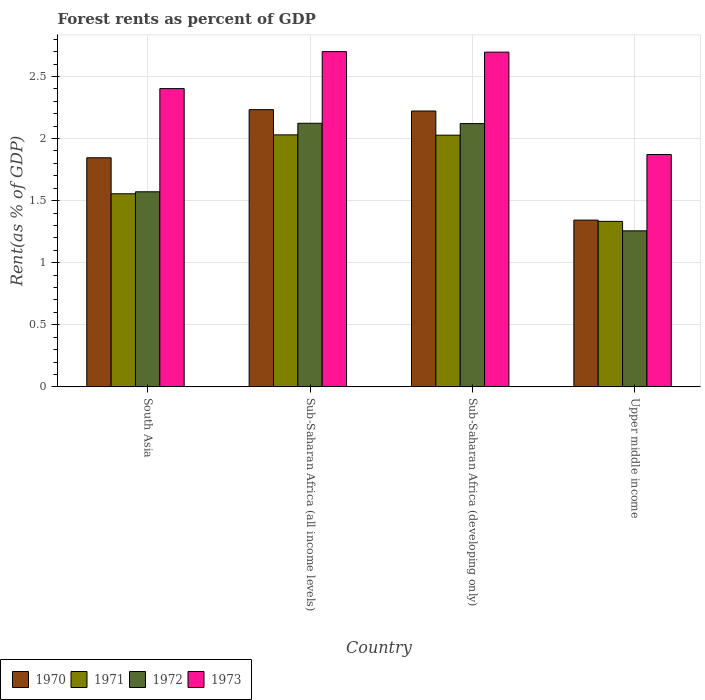How many different coloured bars are there?
Offer a terse response. 4. Are the number of bars per tick equal to the number of legend labels?
Offer a very short reply. Yes. How many bars are there on the 3rd tick from the left?
Provide a succinct answer. 4. What is the label of the 2nd group of bars from the left?
Provide a succinct answer. Sub-Saharan Africa (all income levels). What is the forest rent in 1973 in Sub-Saharan Africa (all income levels)?
Your answer should be very brief. 2.7. Across all countries, what is the maximum forest rent in 1972?
Provide a succinct answer. 2.12. Across all countries, what is the minimum forest rent in 1971?
Provide a short and direct response. 1.33. In which country was the forest rent in 1973 maximum?
Give a very brief answer. Sub-Saharan Africa (all income levels). In which country was the forest rent in 1972 minimum?
Give a very brief answer. Upper middle income. What is the total forest rent in 1973 in the graph?
Offer a very short reply. 9.67. What is the difference between the forest rent in 1971 in Sub-Saharan Africa (developing only) and that in Upper middle income?
Offer a terse response. 0.69. What is the difference between the forest rent in 1970 in Sub-Saharan Africa (developing only) and the forest rent in 1973 in Sub-Saharan Africa (all income levels)?
Offer a very short reply. -0.48. What is the average forest rent in 1970 per country?
Make the answer very short. 1.91. What is the difference between the forest rent of/in 1972 and forest rent of/in 1971 in Sub-Saharan Africa (all income levels)?
Offer a very short reply. 0.09. What is the ratio of the forest rent in 1970 in Sub-Saharan Africa (all income levels) to that in Sub-Saharan Africa (developing only)?
Offer a terse response. 1. Is the forest rent in 1973 in South Asia less than that in Sub-Saharan Africa (all income levels)?
Make the answer very short. Yes. Is the difference between the forest rent in 1972 in South Asia and Sub-Saharan Africa (developing only) greater than the difference between the forest rent in 1971 in South Asia and Sub-Saharan Africa (developing only)?
Ensure brevity in your answer.  No. What is the difference between the highest and the second highest forest rent in 1970?
Offer a very short reply. -0.39. What is the difference between the highest and the lowest forest rent in 1972?
Keep it short and to the point. 0.87. Is the sum of the forest rent in 1970 in South Asia and Sub-Saharan Africa (all income levels) greater than the maximum forest rent in 1971 across all countries?
Your answer should be compact. Yes. Is it the case that in every country, the sum of the forest rent in 1973 and forest rent in 1970 is greater than the sum of forest rent in 1971 and forest rent in 1972?
Offer a terse response. No. How many bars are there?
Ensure brevity in your answer.  16. How many countries are there in the graph?
Make the answer very short. 4. What is the difference between two consecutive major ticks on the Y-axis?
Offer a very short reply. 0.5. Are the values on the major ticks of Y-axis written in scientific E-notation?
Make the answer very short. No. Does the graph contain any zero values?
Your answer should be compact. No. Does the graph contain grids?
Provide a short and direct response. Yes. Where does the legend appear in the graph?
Offer a terse response. Bottom left. How are the legend labels stacked?
Provide a succinct answer. Horizontal. What is the title of the graph?
Provide a succinct answer. Forest rents as percent of GDP. Does "2001" appear as one of the legend labels in the graph?
Give a very brief answer. No. What is the label or title of the X-axis?
Keep it short and to the point. Country. What is the label or title of the Y-axis?
Make the answer very short. Rent(as % of GDP). What is the Rent(as % of GDP) in 1970 in South Asia?
Your answer should be very brief. 1.85. What is the Rent(as % of GDP) of 1971 in South Asia?
Keep it short and to the point. 1.56. What is the Rent(as % of GDP) of 1972 in South Asia?
Your answer should be very brief. 1.57. What is the Rent(as % of GDP) of 1973 in South Asia?
Your response must be concise. 2.4. What is the Rent(as % of GDP) of 1970 in Sub-Saharan Africa (all income levels)?
Keep it short and to the point. 2.23. What is the Rent(as % of GDP) in 1971 in Sub-Saharan Africa (all income levels)?
Provide a short and direct response. 2.03. What is the Rent(as % of GDP) of 1972 in Sub-Saharan Africa (all income levels)?
Keep it short and to the point. 2.12. What is the Rent(as % of GDP) in 1973 in Sub-Saharan Africa (all income levels)?
Provide a succinct answer. 2.7. What is the Rent(as % of GDP) of 1970 in Sub-Saharan Africa (developing only)?
Keep it short and to the point. 2.22. What is the Rent(as % of GDP) in 1971 in Sub-Saharan Africa (developing only)?
Keep it short and to the point. 2.03. What is the Rent(as % of GDP) of 1972 in Sub-Saharan Africa (developing only)?
Make the answer very short. 2.12. What is the Rent(as % of GDP) of 1973 in Sub-Saharan Africa (developing only)?
Offer a terse response. 2.7. What is the Rent(as % of GDP) of 1970 in Upper middle income?
Your answer should be very brief. 1.34. What is the Rent(as % of GDP) of 1971 in Upper middle income?
Your response must be concise. 1.33. What is the Rent(as % of GDP) of 1972 in Upper middle income?
Offer a terse response. 1.26. What is the Rent(as % of GDP) of 1973 in Upper middle income?
Offer a terse response. 1.87. Across all countries, what is the maximum Rent(as % of GDP) in 1970?
Keep it short and to the point. 2.23. Across all countries, what is the maximum Rent(as % of GDP) in 1971?
Your answer should be compact. 2.03. Across all countries, what is the maximum Rent(as % of GDP) in 1972?
Keep it short and to the point. 2.12. Across all countries, what is the maximum Rent(as % of GDP) of 1973?
Make the answer very short. 2.7. Across all countries, what is the minimum Rent(as % of GDP) in 1970?
Your answer should be very brief. 1.34. Across all countries, what is the minimum Rent(as % of GDP) of 1971?
Ensure brevity in your answer.  1.33. Across all countries, what is the minimum Rent(as % of GDP) in 1972?
Your answer should be compact. 1.26. Across all countries, what is the minimum Rent(as % of GDP) in 1973?
Give a very brief answer. 1.87. What is the total Rent(as % of GDP) of 1970 in the graph?
Ensure brevity in your answer.  7.64. What is the total Rent(as % of GDP) of 1971 in the graph?
Provide a succinct answer. 6.95. What is the total Rent(as % of GDP) of 1972 in the graph?
Provide a succinct answer. 7.07. What is the total Rent(as % of GDP) of 1973 in the graph?
Ensure brevity in your answer.  9.67. What is the difference between the Rent(as % of GDP) in 1970 in South Asia and that in Sub-Saharan Africa (all income levels)?
Your answer should be very brief. -0.39. What is the difference between the Rent(as % of GDP) of 1971 in South Asia and that in Sub-Saharan Africa (all income levels)?
Your answer should be very brief. -0.47. What is the difference between the Rent(as % of GDP) of 1972 in South Asia and that in Sub-Saharan Africa (all income levels)?
Offer a very short reply. -0.55. What is the difference between the Rent(as % of GDP) in 1973 in South Asia and that in Sub-Saharan Africa (all income levels)?
Offer a terse response. -0.3. What is the difference between the Rent(as % of GDP) of 1970 in South Asia and that in Sub-Saharan Africa (developing only)?
Ensure brevity in your answer.  -0.38. What is the difference between the Rent(as % of GDP) of 1971 in South Asia and that in Sub-Saharan Africa (developing only)?
Your response must be concise. -0.47. What is the difference between the Rent(as % of GDP) in 1972 in South Asia and that in Sub-Saharan Africa (developing only)?
Your response must be concise. -0.55. What is the difference between the Rent(as % of GDP) in 1973 in South Asia and that in Sub-Saharan Africa (developing only)?
Offer a very short reply. -0.29. What is the difference between the Rent(as % of GDP) of 1970 in South Asia and that in Upper middle income?
Your answer should be compact. 0.5. What is the difference between the Rent(as % of GDP) in 1971 in South Asia and that in Upper middle income?
Keep it short and to the point. 0.22. What is the difference between the Rent(as % of GDP) in 1972 in South Asia and that in Upper middle income?
Make the answer very short. 0.31. What is the difference between the Rent(as % of GDP) of 1973 in South Asia and that in Upper middle income?
Provide a succinct answer. 0.53. What is the difference between the Rent(as % of GDP) in 1970 in Sub-Saharan Africa (all income levels) and that in Sub-Saharan Africa (developing only)?
Give a very brief answer. 0.01. What is the difference between the Rent(as % of GDP) in 1971 in Sub-Saharan Africa (all income levels) and that in Sub-Saharan Africa (developing only)?
Offer a very short reply. 0. What is the difference between the Rent(as % of GDP) in 1972 in Sub-Saharan Africa (all income levels) and that in Sub-Saharan Africa (developing only)?
Make the answer very short. 0. What is the difference between the Rent(as % of GDP) of 1973 in Sub-Saharan Africa (all income levels) and that in Sub-Saharan Africa (developing only)?
Give a very brief answer. 0. What is the difference between the Rent(as % of GDP) in 1970 in Sub-Saharan Africa (all income levels) and that in Upper middle income?
Keep it short and to the point. 0.89. What is the difference between the Rent(as % of GDP) in 1971 in Sub-Saharan Africa (all income levels) and that in Upper middle income?
Give a very brief answer. 0.7. What is the difference between the Rent(as % of GDP) of 1972 in Sub-Saharan Africa (all income levels) and that in Upper middle income?
Your answer should be very brief. 0.87. What is the difference between the Rent(as % of GDP) of 1973 in Sub-Saharan Africa (all income levels) and that in Upper middle income?
Your answer should be compact. 0.83. What is the difference between the Rent(as % of GDP) in 1970 in Sub-Saharan Africa (developing only) and that in Upper middle income?
Offer a terse response. 0.88. What is the difference between the Rent(as % of GDP) in 1971 in Sub-Saharan Africa (developing only) and that in Upper middle income?
Ensure brevity in your answer.  0.69. What is the difference between the Rent(as % of GDP) of 1972 in Sub-Saharan Africa (developing only) and that in Upper middle income?
Your answer should be compact. 0.86. What is the difference between the Rent(as % of GDP) in 1973 in Sub-Saharan Africa (developing only) and that in Upper middle income?
Ensure brevity in your answer.  0.82. What is the difference between the Rent(as % of GDP) of 1970 in South Asia and the Rent(as % of GDP) of 1971 in Sub-Saharan Africa (all income levels)?
Your answer should be compact. -0.18. What is the difference between the Rent(as % of GDP) of 1970 in South Asia and the Rent(as % of GDP) of 1972 in Sub-Saharan Africa (all income levels)?
Offer a terse response. -0.28. What is the difference between the Rent(as % of GDP) of 1970 in South Asia and the Rent(as % of GDP) of 1973 in Sub-Saharan Africa (all income levels)?
Your response must be concise. -0.85. What is the difference between the Rent(as % of GDP) of 1971 in South Asia and the Rent(as % of GDP) of 1972 in Sub-Saharan Africa (all income levels)?
Your answer should be compact. -0.57. What is the difference between the Rent(as % of GDP) of 1971 in South Asia and the Rent(as % of GDP) of 1973 in Sub-Saharan Africa (all income levels)?
Offer a terse response. -1.14. What is the difference between the Rent(as % of GDP) in 1972 in South Asia and the Rent(as % of GDP) in 1973 in Sub-Saharan Africa (all income levels)?
Offer a terse response. -1.13. What is the difference between the Rent(as % of GDP) in 1970 in South Asia and the Rent(as % of GDP) in 1971 in Sub-Saharan Africa (developing only)?
Your answer should be compact. -0.18. What is the difference between the Rent(as % of GDP) in 1970 in South Asia and the Rent(as % of GDP) in 1972 in Sub-Saharan Africa (developing only)?
Offer a terse response. -0.28. What is the difference between the Rent(as % of GDP) in 1970 in South Asia and the Rent(as % of GDP) in 1973 in Sub-Saharan Africa (developing only)?
Provide a short and direct response. -0.85. What is the difference between the Rent(as % of GDP) in 1971 in South Asia and the Rent(as % of GDP) in 1972 in Sub-Saharan Africa (developing only)?
Keep it short and to the point. -0.57. What is the difference between the Rent(as % of GDP) in 1971 in South Asia and the Rent(as % of GDP) in 1973 in Sub-Saharan Africa (developing only)?
Keep it short and to the point. -1.14. What is the difference between the Rent(as % of GDP) of 1972 in South Asia and the Rent(as % of GDP) of 1973 in Sub-Saharan Africa (developing only)?
Your answer should be compact. -1.12. What is the difference between the Rent(as % of GDP) in 1970 in South Asia and the Rent(as % of GDP) in 1971 in Upper middle income?
Make the answer very short. 0.51. What is the difference between the Rent(as % of GDP) in 1970 in South Asia and the Rent(as % of GDP) in 1972 in Upper middle income?
Ensure brevity in your answer.  0.59. What is the difference between the Rent(as % of GDP) of 1970 in South Asia and the Rent(as % of GDP) of 1973 in Upper middle income?
Make the answer very short. -0.03. What is the difference between the Rent(as % of GDP) of 1971 in South Asia and the Rent(as % of GDP) of 1972 in Upper middle income?
Provide a succinct answer. 0.3. What is the difference between the Rent(as % of GDP) in 1971 in South Asia and the Rent(as % of GDP) in 1973 in Upper middle income?
Provide a short and direct response. -0.32. What is the difference between the Rent(as % of GDP) in 1972 in South Asia and the Rent(as % of GDP) in 1973 in Upper middle income?
Provide a succinct answer. -0.3. What is the difference between the Rent(as % of GDP) of 1970 in Sub-Saharan Africa (all income levels) and the Rent(as % of GDP) of 1971 in Sub-Saharan Africa (developing only)?
Ensure brevity in your answer.  0.21. What is the difference between the Rent(as % of GDP) of 1970 in Sub-Saharan Africa (all income levels) and the Rent(as % of GDP) of 1972 in Sub-Saharan Africa (developing only)?
Provide a succinct answer. 0.11. What is the difference between the Rent(as % of GDP) in 1970 in Sub-Saharan Africa (all income levels) and the Rent(as % of GDP) in 1973 in Sub-Saharan Africa (developing only)?
Provide a succinct answer. -0.46. What is the difference between the Rent(as % of GDP) in 1971 in Sub-Saharan Africa (all income levels) and the Rent(as % of GDP) in 1972 in Sub-Saharan Africa (developing only)?
Keep it short and to the point. -0.09. What is the difference between the Rent(as % of GDP) in 1971 in Sub-Saharan Africa (all income levels) and the Rent(as % of GDP) in 1973 in Sub-Saharan Africa (developing only)?
Your response must be concise. -0.67. What is the difference between the Rent(as % of GDP) in 1972 in Sub-Saharan Africa (all income levels) and the Rent(as % of GDP) in 1973 in Sub-Saharan Africa (developing only)?
Ensure brevity in your answer.  -0.57. What is the difference between the Rent(as % of GDP) in 1970 in Sub-Saharan Africa (all income levels) and the Rent(as % of GDP) in 1971 in Upper middle income?
Provide a succinct answer. 0.9. What is the difference between the Rent(as % of GDP) of 1970 in Sub-Saharan Africa (all income levels) and the Rent(as % of GDP) of 1972 in Upper middle income?
Give a very brief answer. 0.98. What is the difference between the Rent(as % of GDP) of 1970 in Sub-Saharan Africa (all income levels) and the Rent(as % of GDP) of 1973 in Upper middle income?
Your answer should be compact. 0.36. What is the difference between the Rent(as % of GDP) in 1971 in Sub-Saharan Africa (all income levels) and the Rent(as % of GDP) in 1972 in Upper middle income?
Offer a terse response. 0.77. What is the difference between the Rent(as % of GDP) in 1971 in Sub-Saharan Africa (all income levels) and the Rent(as % of GDP) in 1973 in Upper middle income?
Provide a short and direct response. 0.16. What is the difference between the Rent(as % of GDP) in 1972 in Sub-Saharan Africa (all income levels) and the Rent(as % of GDP) in 1973 in Upper middle income?
Your answer should be very brief. 0.25. What is the difference between the Rent(as % of GDP) of 1970 in Sub-Saharan Africa (developing only) and the Rent(as % of GDP) of 1972 in Upper middle income?
Your answer should be very brief. 0.97. What is the difference between the Rent(as % of GDP) of 1970 in Sub-Saharan Africa (developing only) and the Rent(as % of GDP) of 1973 in Upper middle income?
Provide a succinct answer. 0.35. What is the difference between the Rent(as % of GDP) of 1971 in Sub-Saharan Africa (developing only) and the Rent(as % of GDP) of 1972 in Upper middle income?
Your response must be concise. 0.77. What is the difference between the Rent(as % of GDP) of 1971 in Sub-Saharan Africa (developing only) and the Rent(as % of GDP) of 1973 in Upper middle income?
Offer a very short reply. 0.16. What is the difference between the Rent(as % of GDP) of 1972 in Sub-Saharan Africa (developing only) and the Rent(as % of GDP) of 1973 in Upper middle income?
Your answer should be compact. 0.25. What is the average Rent(as % of GDP) of 1970 per country?
Provide a short and direct response. 1.91. What is the average Rent(as % of GDP) of 1971 per country?
Provide a short and direct response. 1.74. What is the average Rent(as % of GDP) in 1972 per country?
Ensure brevity in your answer.  1.77. What is the average Rent(as % of GDP) of 1973 per country?
Your answer should be compact. 2.42. What is the difference between the Rent(as % of GDP) of 1970 and Rent(as % of GDP) of 1971 in South Asia?
Provide a short and direct response. 0.29. What is the difference between the Rent(as % of GDP) of 1970 and Rent(as % of GDP) of 1972 in South Asia?
Make the answer very short. 0.27. What is the difference between the Rent(as % of GDP) of 1970 and Rent(as % of GDP) of 1973 in South Asia?
Give a very brief answer. -0.56. What is the difference between the Rent(as % of GDP) of 1971 and Rent(as % of GDP) of 1972 in South Asia?
Offer a very short reply. -0.02. What is the difference between the Rent(as % of GDP) of 1971 and Rent(as % of GDP) of 1973 in South Asia?
Provide a succinct answer. -0.85. What is the difference between the Rent(as % of GDP) in 1972 and Rent(as % of GDP) in 1973 in South Asia?
Your answer should be very brief. -0.83. What is the difference between the Rent(as % of GDP) of 1970 and Rent(as % of GDP) of 1971 in Sub-Saharan Africa (all income levels)?
Offer a terse response. 0.2. What is the difference between the Rent(as % of GDP) of 1970 and Rent(as % of GDP) of 1972 in Sub-Saharan Africa (all income levels)?
Provide a succinct answer. 0.11. What is the difference between the Rent(as % of GDP) of 1970 and Rent(as % of GDP) of 1973 in Sub-Saharan Africa (all income levels)?
Keep it short and to the point. -0.47. What is the difference between the Rent(as % of GDP) in 1971 and Rent(as % of GDP) in 1972 in Sub-Saharan Africa (all income levels)?
Offer a very short reply. -0.09. What is the difference between the Rent(as % of GDP) in 1971 and Rent(as % of GDP) in 1973 in Sub-Saharan Africa (all income levels)?
Offer a terse response. -0.67. What is the difference between the Rent(as % of GDP) in 1972 and Rent(as % of GDP) in 1973 in Sub-Saharan Africa (all income levels)?
Your response must be concise. -0.58. What is the difference between the Rent(as % of GDP) of 1970 and Rent(as % of GDP) of 1971 in Sub-Saharan Africa (developing only)?
Provide a short and direct response. 0.19. What is the difference between the Rent(as % of GDP) of 1970 and Rent(as % of GDP) of 1972 in Sub-Saharan Africa (developing only)?
Offer a very short reply. 0.1. What is the difference between the Rent(as % of GDP) in 1970 and Rent(as % of GDP) in 1973 in Sub-Saharan Africa (developing only)?
Give a very brief answer. -0.47. What is the difference between the Rent(as % of GDP) in 1971 and Rent(as % of GDP) in 1972 in Sub-Saharan Africa (developing only)?
Make the answer very short. -0.09. What is the difference between the Rent(as % of GDP) of 1971 and Rent(as % of GDP) of 1973 in Sub-Saharan Africa (developing only)?
Make the answer very short. -0.67. What is the difference between the Rent(as % of GDP) of 1972 and Rent(as % of GDP) of 1973 in Sub-Saharan Africa (developing only)?
Keep it short and to the point. -0.58. What is the difference between the Rent(as % of GDP) of 1970 and Rent(as % of GDP) of 1971 in Upper middle income?
Offer a very short reply. 0.01. What is the difference between the Rent(as % of GDP) in 1970 and Rent(as % of GDP) in 1972 in Upper middle income?
Ensure brevity in your answer.  0.09. What is the difference between the Rent(as % of GDP) of 1970 and Rent(as % of GDP) of 1973 in Upper middle income?
Keep it short and to the point. -0.53. What is the difference between the Rent(as % of GDP) in 1971 and Rent(as % of GDP) in 1972 in Upper middle income?
Your answer should be compact. 0.08. What is the difference between the Rent(as % of GDP) of 1971 and Rent(as % of GDP) of 1973 in Upper middle income?
Ensure brevity in your answer.  -0.54. What is the difference between the Rent(as % of GDP) of 1972 and Rent(as % of GDP) of 1973 in Upper middle income?
Your response must be concise. -0.61. What is the ratio of the Rent(as % of GDP) of 1970 in South Asia to that in Sub-Saharan Africa (all income levels)?
Offer a very short reply. 0.83. What is the ratio of the Rent(as % of GDP) of 1971 in South Asia to that in Sub-Saharan Africa (all income levels)?
Make the answer very short. 0.77. What is the ratio of the Rent(as % of GDP) in 1972 in South Asia to that in Sub-Saharan Africa (all income levels)?
Offer a very short reply. 0.74. What is the ratio of the Rent(as % of GDP) in 1973 in South Asia to that in Sub-Saharan Africa (all income levels)?
Provide a short and direct response. 0.89. What is the ratio of the Rent(as % of GDP) of 1970 in South Asia to that in Sub-Saharan Africa (developing only)?
Your answer should be very brief. 0.83. What is the ratio of the Rent(as % of GDP) in 1971 in South Asia to that in Sub-Saharan Africa (developing only)?
Give a very brief answer. 0.77. What is the ratio of the Rent(as % of GDP) of 1972 in South Asia to that in Sub-Saharan Africa (developing only)?
Ensure brevity in your answer.  0.74. What is the ratio of the Rent(as % of GDP) in 1973 in South Asia to that in Sub-Saharan Africa (developing only)?
Give a very brief answer. 0.89. What is the ratio of the Rent(as % of GDP) of 1970 in South Asia to that in Upper middle income?
Offer a terse response. 1.37. What is the ratio of the Rent(as % of GDP) of 1972 in South Asia to that in Upper middle income?
Make the answer very short. 1.25. What is the ratio of the Rent(as % of GDP) in 1973 in South Asia to that in Upper middle income?
Your answer should be compact. 1.28. What is the ratio of the Rent(as % of GDP) of 1972 in Sub-Saharan Africa (all income levels) to that in Sub-Saharan Africa (developing only)?
Provide a short and direct response. 1. What is the ratio of the Rent(as % of GDP) in 1970 in Sub-Saharan Africa (all income levels) to that in Upper middle income?
Give a very brief answer. 1.66. What is the ratio of the Rent(as % of GDP) of 1971 in Sub-Saharan Africa (all income levels) to that in Upper middle income?
Keep it short and to the point. 1.52. What is the ratio of the Rent(as % of GDP) of 1972 in Sub-Saharan Africa (all income levels) to that in Upper middle income?
Your response must be concise. 1.69. What is the ratio of the Rent(as % of GDP) of 1973 in Sub-Saharan Africa (all income levels) to that in Upper middle income?
Keep it short and to the point. 1.44. What is the ratio of the Rent(as % of GDP) in 1970 in Sub-Saharan Africa (developing only) to that in Upper middle income?
Provide a short and direct response. 1.65. What is the ratio of the Rent(as % of GDP) in 1971 in Sub-Saharan Africa (developing only) to that in Upper middle income?
Provide a short and direct response. 1.52. What is the ratio of the Rent(as % of GDP) in 1972 in Sub-Saharan Africa (developing only) to that in Upper middle income?
Your answer should be compact. 1.69. What is the ratio of the Rent(as % of GDP) of 1973 in Sub-Saharan Africa (developing only) to that in Upper middle income?
Give a very brief answer. 1.44. What is the difference between the highest and the second highest Rent(as % of GDP) of 1970?
Your answer should be compact. 0.01. What is the difference between the highest and the second highest Rent(as % of GDP) in 1971?
Make the answer very short. 0. What is the difference between the highest and the second highest Rent(as % of GDP) of 1972?
Offer a very short reply. 0. What is the difference between the highest and the second highest Rent(as % of GDP) in 1973?
Offer a terse response. 0. What is the difference between the highest and the lowest Rent(as % of GDP) of 1970?
Your response must be concise. 0.89. What is the difference between the highest and the lowest Rent(as % of GDP) of 1971?
Ensure brevity in your answer.  0.7. What is the difference between the highest and the lowest Rent(as % of GDP) of 1972?
Give a very brief answer. 0.87. What is the difference between the highest and the lowest Rent(as % of GDP) of 1973?
Keep it short and to the point. 0.83. 